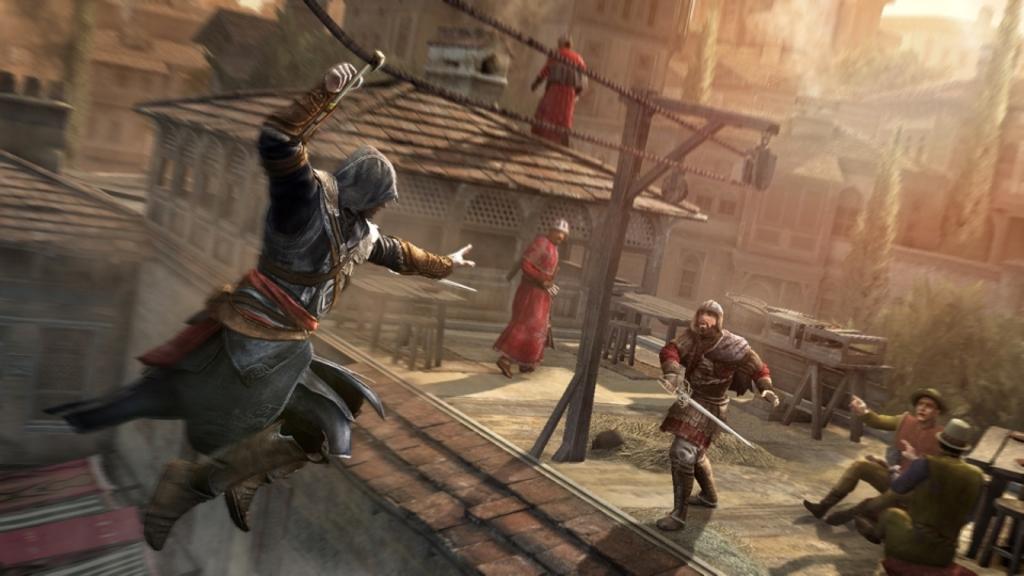Describe this image in one or two sentences. In the picture I can see an image of a person in the air and there is a rope above him and there is a person holding a sword is in front of him and there are two persons sitting in the right corner and there are few other people,houses and trees in the background. 